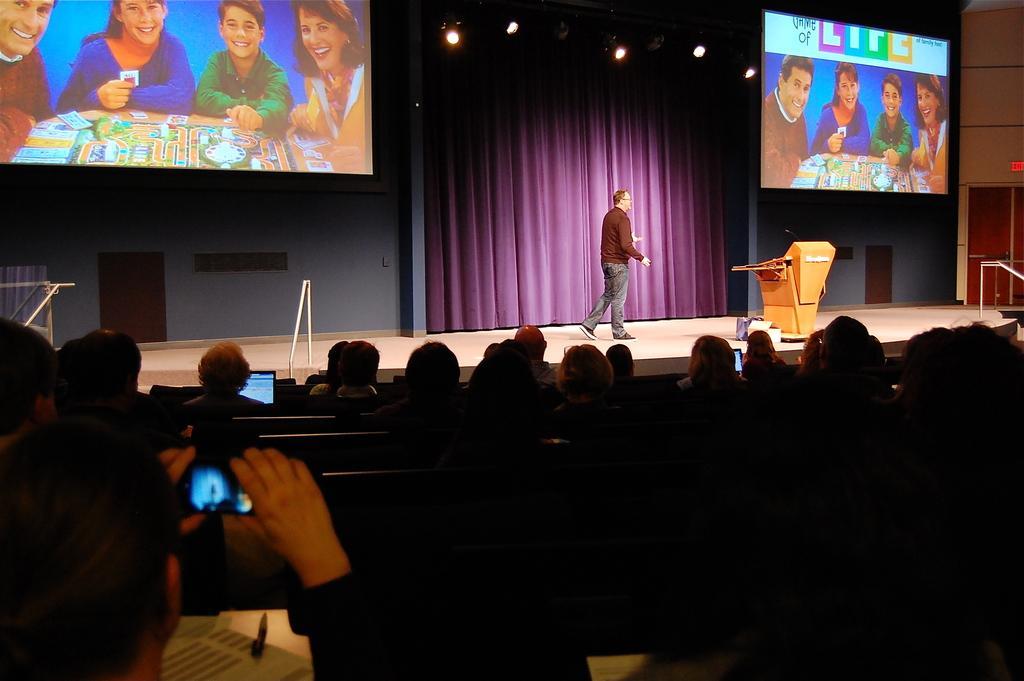In one or two sentences, can you explain what this image depicts? In this picture there is a man who is wearing t-shirt, jeans and sneakers. He is standing on the stage, beside him we can see the speech desk. In the top left and top right we can see the projector screen. In that we can see four person were sitting near to the table, everyone is smiling. At the bottom we can see many people were sitting on the chair. In the bottom left there is a man who is holding mobile phone, beside him we can see a woman who is looking in the laptop. On the left there is a door, beside that there is a window. At the top we can see many lights and purple color cloth. 